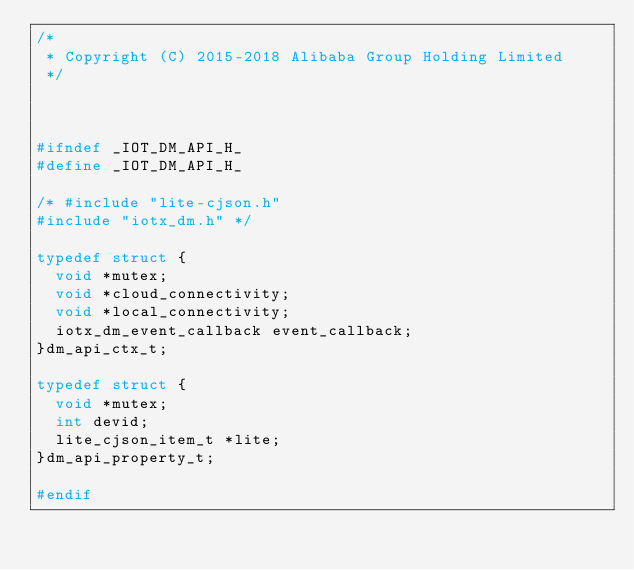Convert code to text. <code><loc_0><loc_0><loc_500><loc_500><_C_>/*
 * Copyright (C) 2015-2018 Alibaba Group Holding Limited
 */



#ifndef _IOT_DM_API_H_
#define _IOT_DM_API_H_

/* #include "lite-cjson.h"
#include "iotx_dm.h" */

typedef struct {
	void *mutex;
	void *cloud_connectivity;
	void *local_connectivity;
	iotx_dm_event_callback event_callback;
}dm_api_ctx_t;

typedef struct {
	void *mutex;
	int devid;
	lite_cjson_item_t *lite;
}dm_api_property_t;

#endif
</code> 